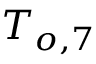<formula> <loc_0><loc_0><loc_500><loc_500>T _ { o , 7 }</formula> 